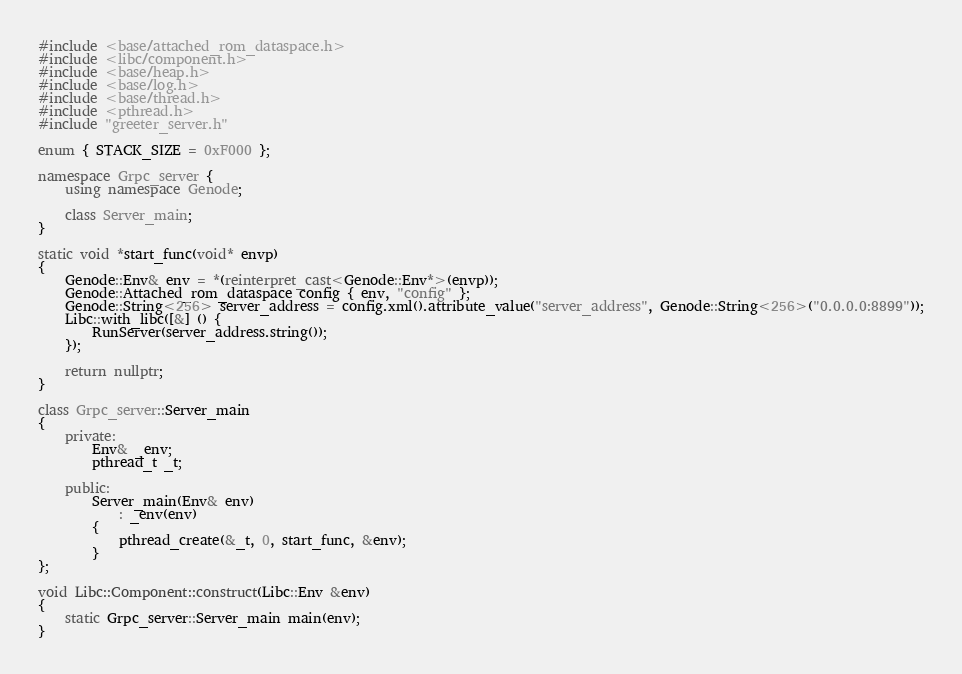<code> <loc_0><loc_0><loc_500><loc_500><_C++_>#include <base/attached_rom_dataspace.h>
#include <libc/component.h>
#include <base/heap.h>
#include <base/log.h>
#include <base/thread.h>
#include <pthread.h>
#include "greeter_server.h"

enum { STACK_SIZE = 0xF000 };

namespace Grpc_server {
	using namespace Genode;

	class Server_main;
}

static void *start_func(void* envp)
{
	Genode::Env& env = *(reinterpret_cast<Genode::Env*>(envp));
	Genode::Attached_rom_dataspace config { env, "config" };
	Genode::String<256> server_address = config.xml().attribute_value("server_address", Genode::String<256>("0.0.0.0:8899"));
	Libc::with_libc([&] () {
		RunServer(server_address.string());
	});

	return nullptr;
}

class Grpc_server::Server_main
{
	private:
		Env& _env;
		pthread_t _t;

	public:
		Server_main(Env& env)
			: _env(env)
		{
			pthread_create(&_t, 0, start_func, &env);
		}
};

void Libc::Component::construct(Libc::Env &env)
{
	static Grpc_server::Server_main main(env);
}
</code> 